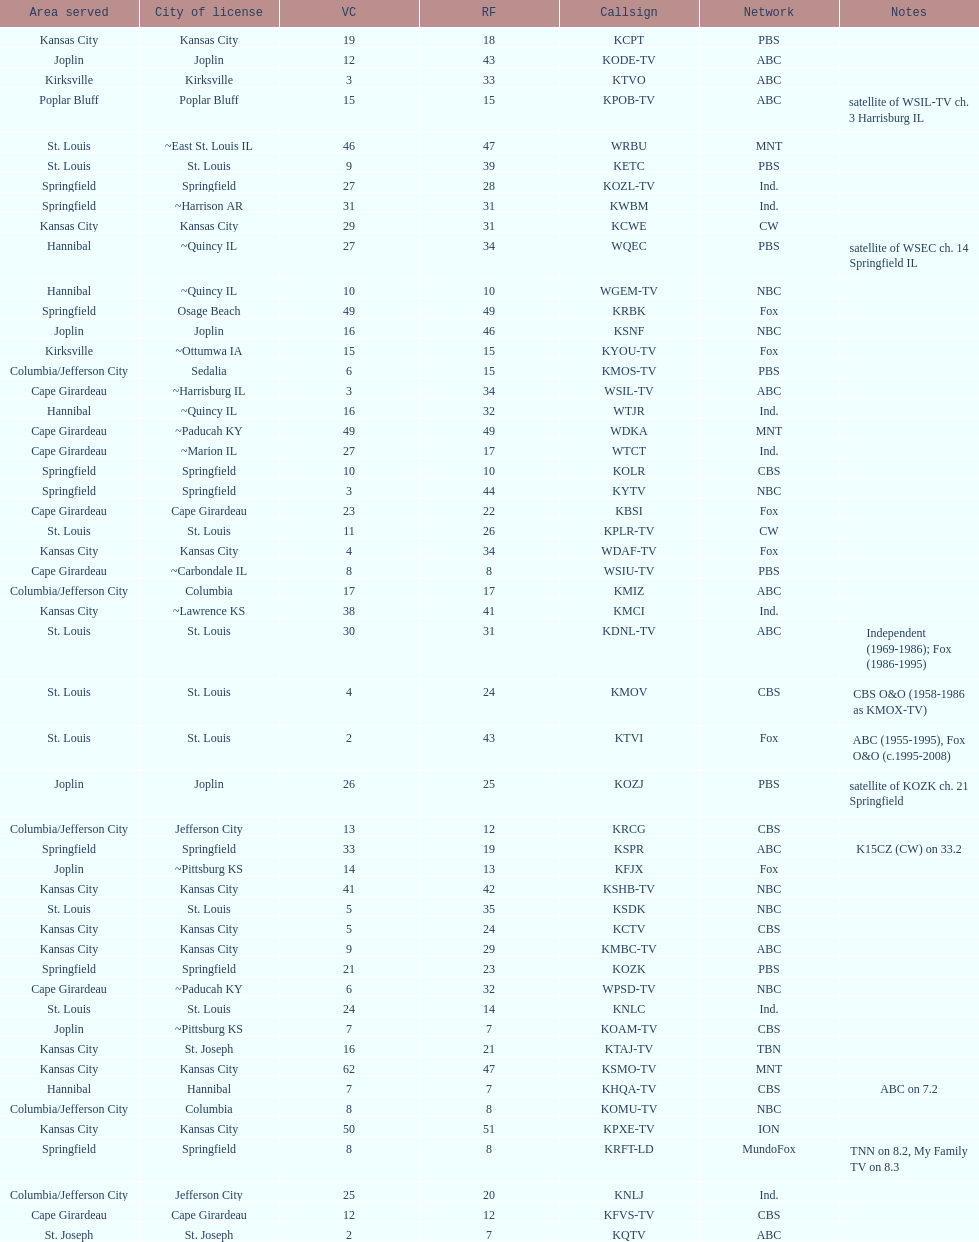How many of these missouri tv stations are actually licensed in a city in illinois (il)? 7. 